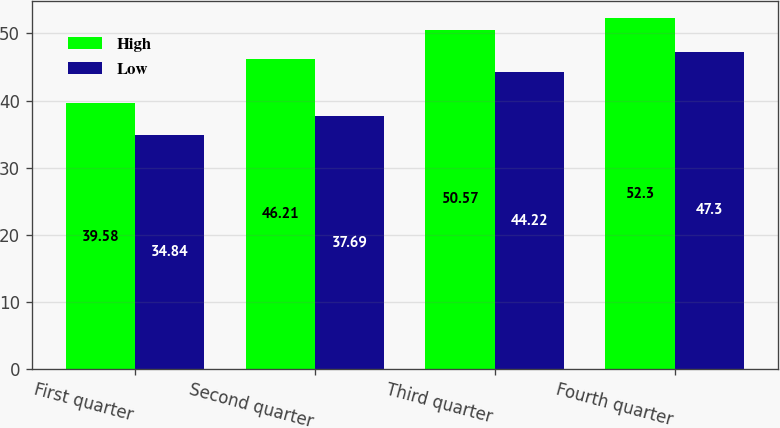Convert chart. <chart><loc_0><loc_0><loc_500><loc_500><stacked_bar_chart><ecel><fcel>First quarter<fcel>Second quarter<fcel>Third quarter<fcel>Fourth quarter<nl><fcel>High<fcel>39.58<fcel>46.21<fcel>50.57<fcel>52.3<nl><fcel>Low<fcel>34.84<fcel>37.69<fcel>44.22<fcel>47.3<nl></chart> 